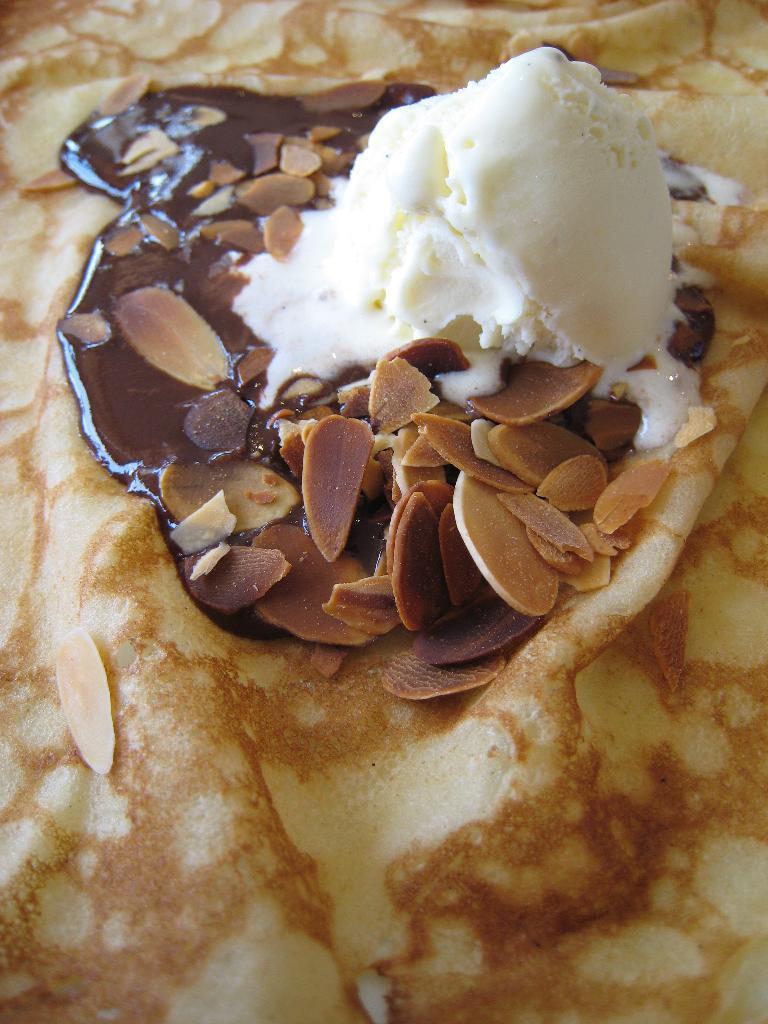Describe this image in one or two sentences. In the image we can see some food. 